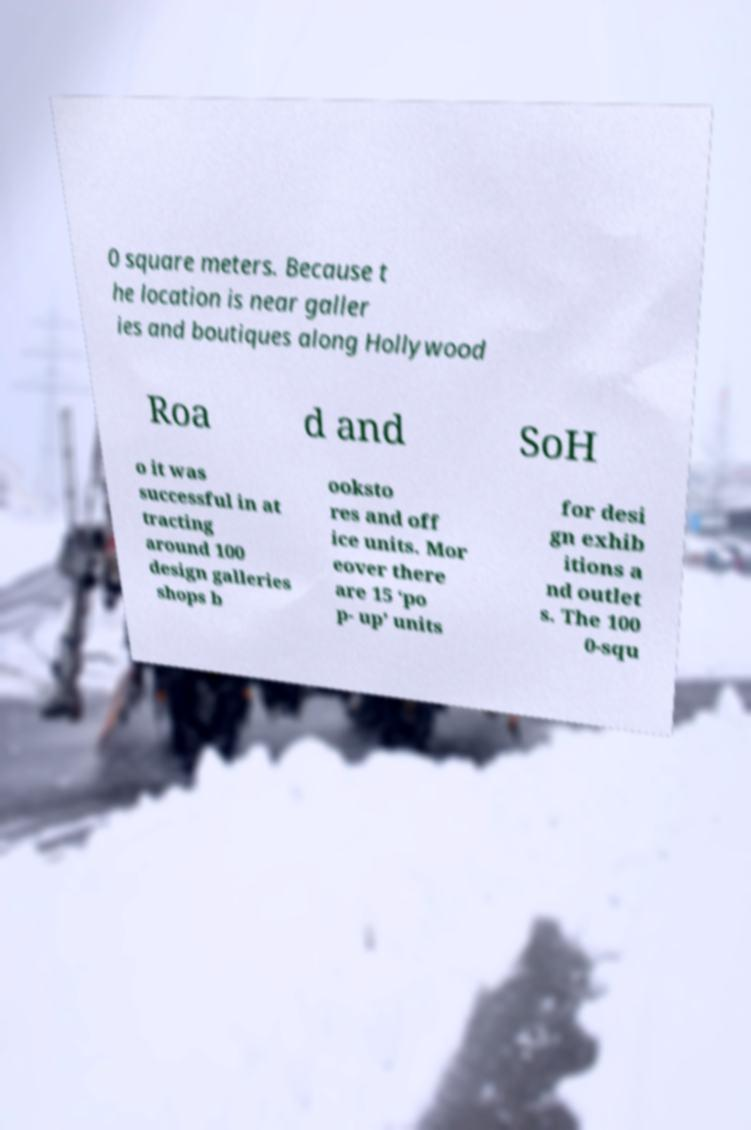Could you extract and type out the text from this image? 0 square meters. Because t he location is near galler ies and boutiques along Hollywood Roa d and SoH o it was successful in at tracting around 100 design galleries shops b ooksto res and off ice units. Mor eover there are 15 ‘po p- up’ units for desi gn exhib itions a nd outlet s. The 100 0-squ 